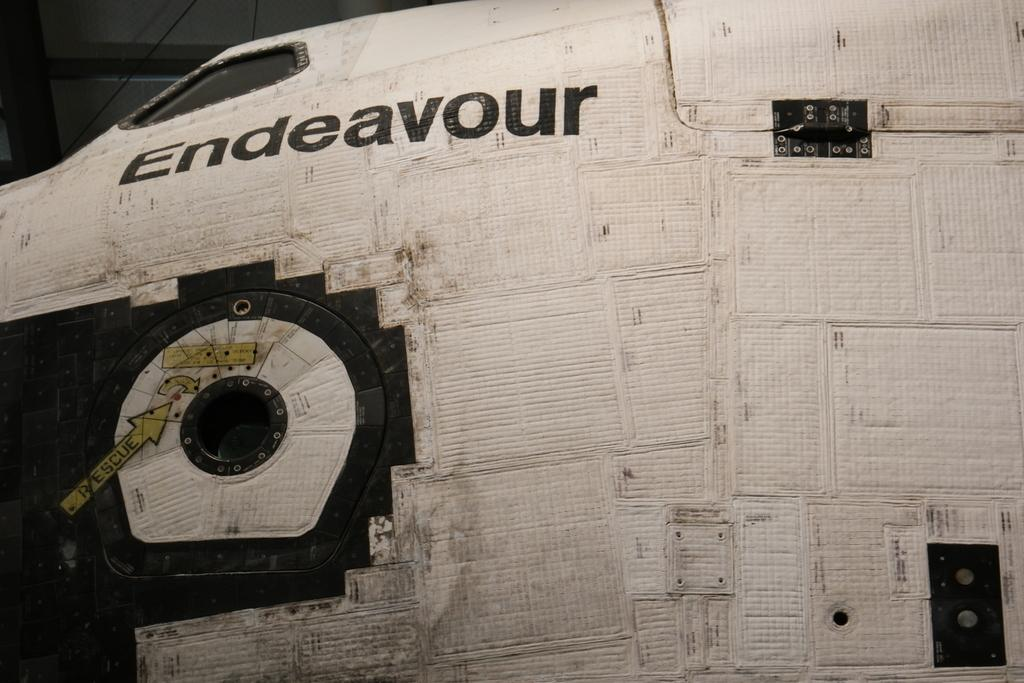<image>
Describe the image concisely. A close up of the spaceship Endeavour, written in black text 